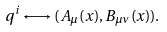Convert formula to latex. <formula><loc_0><loc_0><loc_500><loc_500>q ^ { i } \longleftrightarrow ( A _ { \mu } ( x ) , B _ { \mu \nu } ( x ) ) .</formula> 